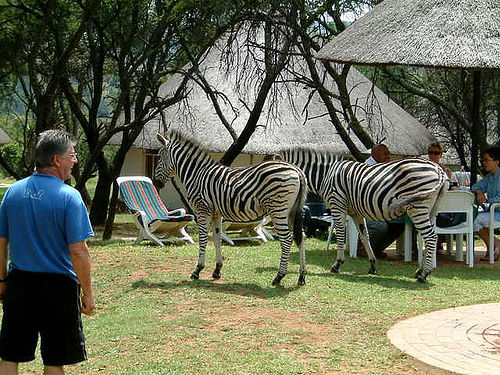How many zebras can be seen? 2 